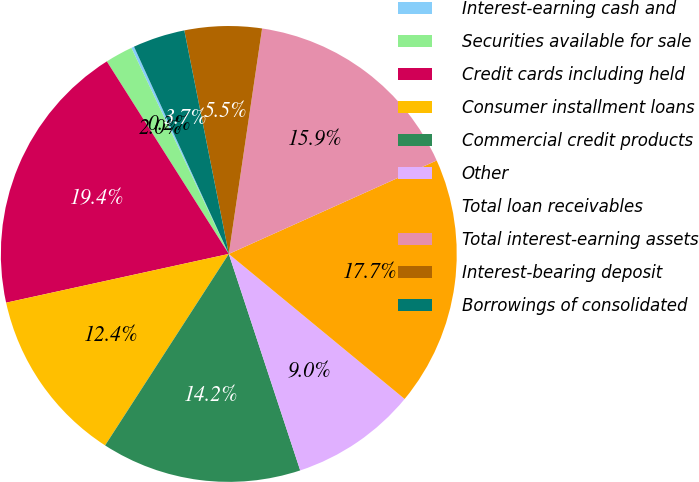Convert chart to OTSL. <chart><loc_0><loc_0><loc_500><loc_500><pie_chart><fcel>Interest-earning cash and<fcel>Securities available for sale<fcel>Credit cards including held<fcel>Consumer installment loans<fcel>Commercial credit products<fcel>Other<fcel>Total loan receivables<fcel>Total interest-earning assets<fcel>Interest-bearing deposit<fcel>Borrowings of consolidated<nl><fcel>0.2%<fcel>1.96%<fcel>19.44%<fcel>12.44%<fcel>14.2%<fcel>8.95%<fcel>17.7%<fcel>15.94%<fcel>5.46%<fcel>3.7%<nl></chart> 